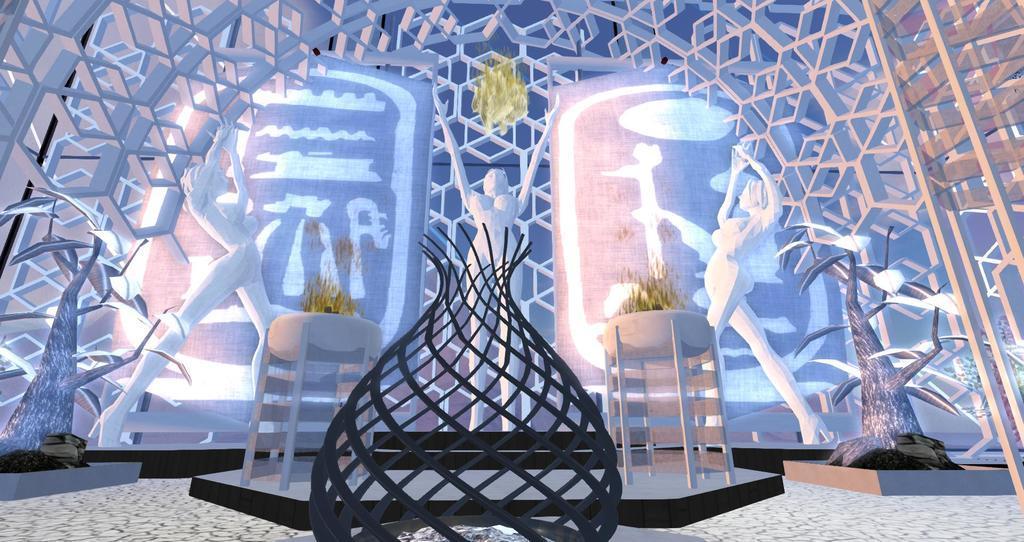In one or two sentences, can you explain what this image depicts? In the picture we can see an architecture near it we can see three human statues on the surface. 